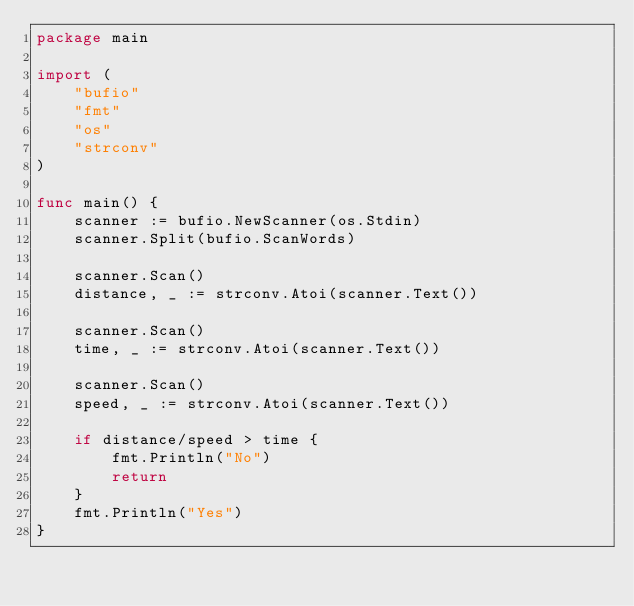Convert code to text. <code><loc_0><loc_0><loc_500><loc_500><_Go_>package main

import (
	"bufio"
	"fmt"
	"os"
	"strconv"
)

func main() {
	scanner := bufio.NewScanner(os.Stdin)
	scanner.Split(bufio.ScanWords)

	scanner.Scan()
	distance, _ := strconv.Atoi(scanner.Text())

	scanner.Scan()
	time, _ := strconv.Atoi(scanner.Text())

	scanner.Scan()
	speed, _ := strconv.Atoi(scanner.Text())

	if distance/speed > time {
		fmt.Println("No")
		return
	}
	fmt.Println("Yes")
}

</code> 